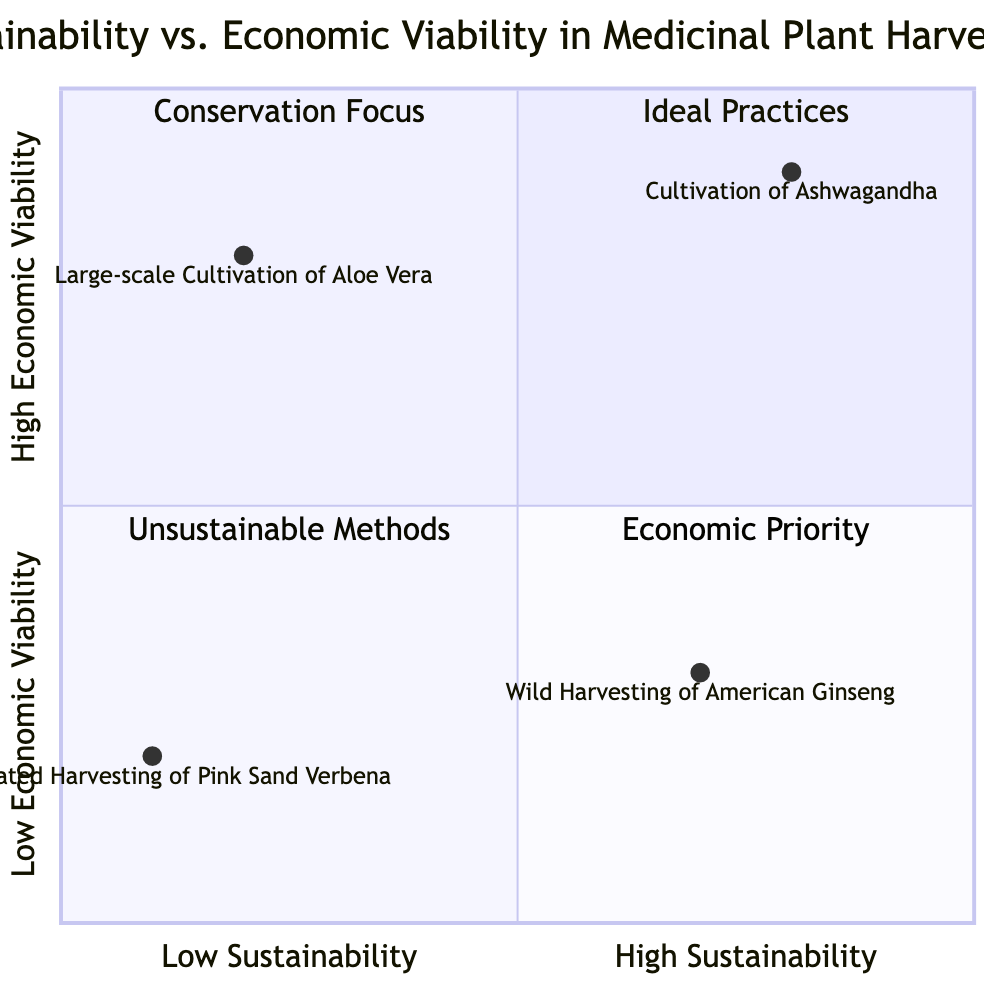What example represents high sustainability and high economic viability? The quadrant for high sustainability and high economic viability lists the example of "Cultivation of Ashwagandha in Controlled Environments." This node describes both the environmental and economic benefits of this practice.
Answer: Cultivation of Ashwagandha in Controlled Environments What is the description of the wild harvesting of American Ginseng? The description for "Wild Harvesting of American Ginseng under Conservation Agreements" states that it is environmentally sustainable but may have lower short-term economic returns due to restricted harvest volumes and maintenance of natural habitats.
Answer: Environmentally sustainable through regulated practices but may have lower short-term economic returns How many examples are in the low sustainability, low economic viability quadrant? The quadrant for low sustainability and low economic viability, labeled as "Unsustainable Methods," contains only one example, which is "Unregulated Harvesting of Pink Sand Verbena."
Answer: 1 Which example has the highest economic viability? Looking at the quadrants, "Large-scale Cultivation of Aloe Vera" is in the low sustainability zone but has high economic viability, represented as the highest point in that quadrant.
Answer: Large-scale Cultivation of Aloe Vera What is the sustainability score for the cultivation of Ashwagandha? In the diagram, the value for sustainability of "Cultivation of Ashwagandha" is indicated by the coordinates [0.8, 0.9]. The sustainability score thus is 0.8.
Answer: 0.8 Which quadrant contains practices that should be prioritized for economic returns? The quadrant labeled as "Economic Priority" is where practices with high economic viability and low sustainability are located, such as "Large-scale Cultivation of Aloe Vera."
Answer: Economic Priority Which example from the diagram reflects unsustainable harvesting methods? The example "Unregulated Harvesting of Pink Sand Verbena" is at the low sustainability and low economic viability quadrant, which defines it as unsustainable and unviable.
Answer: Unregulated Harvesting of Pink Sand Verbena What are the economic viability and sustainability scores for Unregulated Harvesting of Pink Sand Verbena? The diagram provides the coordinates for "Unregulated Harvesting of Pink Sand Verbena" as [0.1, 0.2], indicating scores of 0.1 for sustainability and 0.2 for economic viability.
Answer: Economic Viability: 0.2, Sustainability: 0.1 Can you identify a practice within conservation agreements? The quadrant for high sustainability but low economic viability specifically highlights "Wild Harvesting of American Ginseng under Conservation Agreements" as an example of a practice involved with conservation efforts.
Answer: Wild Harvesting of American Ginseng under Conservation Agreements 